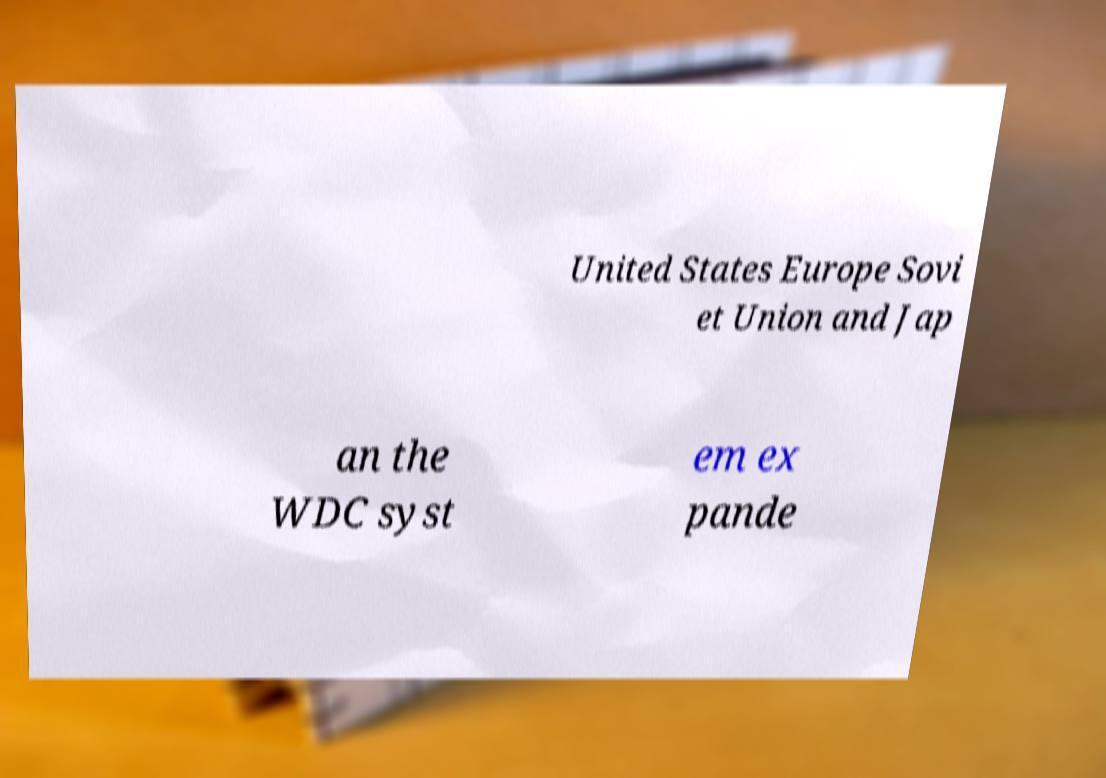For documentation purposes, I need the text within this image transcribed. Could you provide that? United States Europe Sovi et Union and Jap an the WDC syst em ex pande 